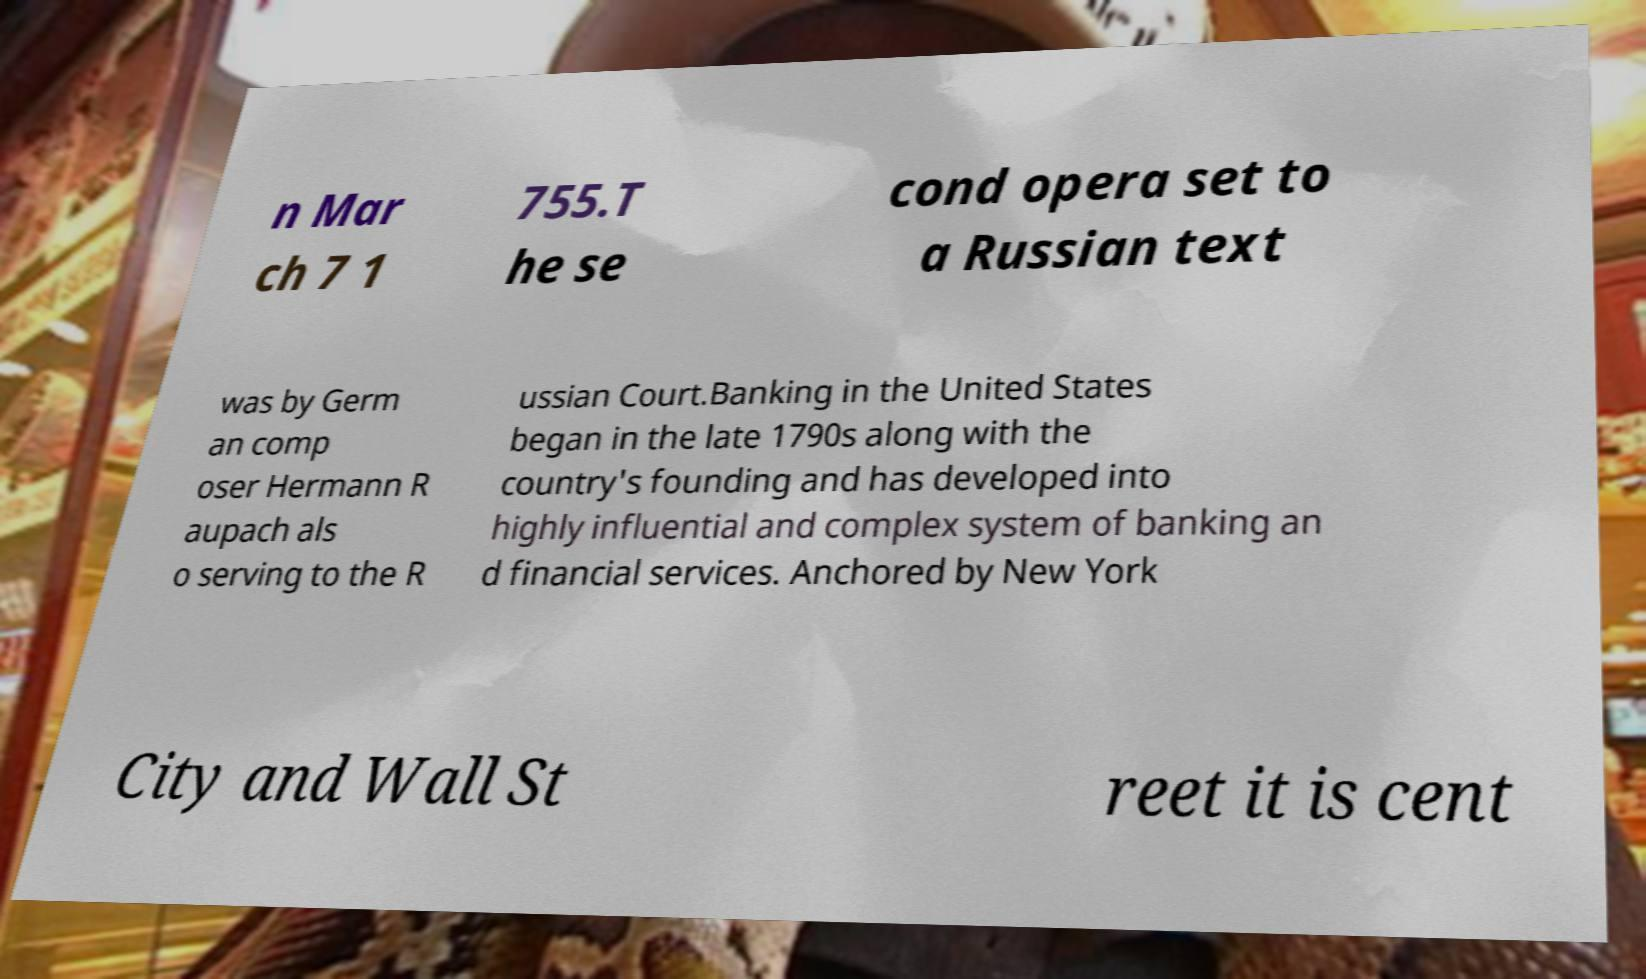There's text embedded in this image that I need extracted. Can you transcribe it verbatim? n Mar ch 7 1 755.T he se cond opera set to a Russian text was by Germ an comp oser Hermann R aupach als o serving to the R ussian Court.Banking in the United States began in the late 1790s along with the country's founding and has developed into highly influential and complex system of banking an d financial services. Anchored by New York City and Wall St reet it is cent 